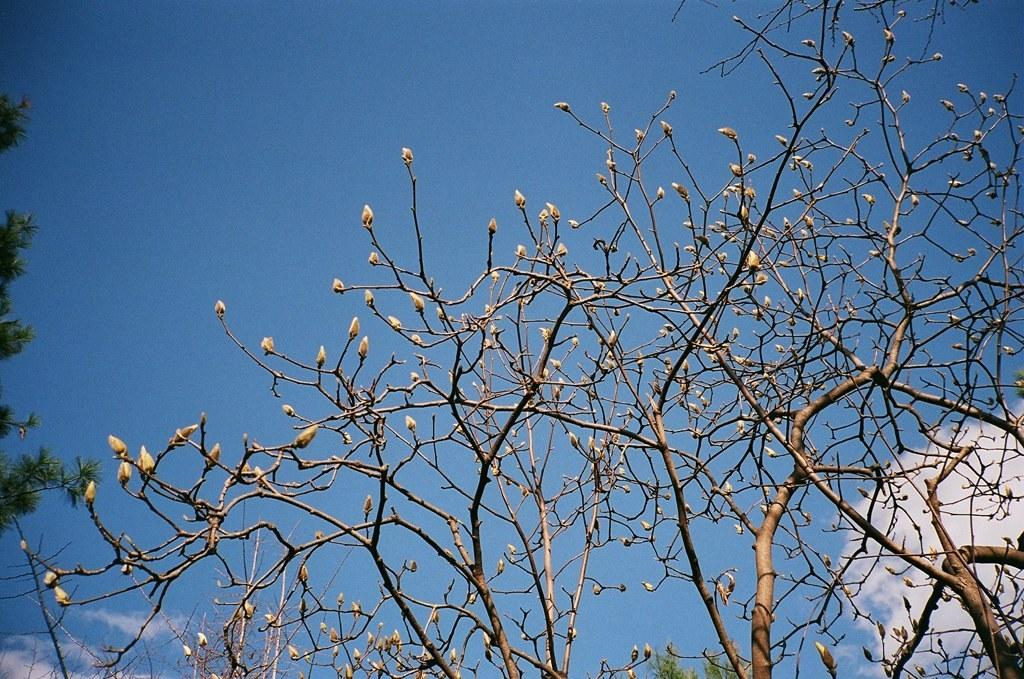What is located on the left side of the image? There is a tree on the left side of the image. What is present on the right back side of the image? There is a tree on the right back side of the image. Can you describe the condition of one of the trees in the image? There is a dried tree in the image. What can be seen in the sky in the image? There are clouds in the sky in the image. What type of quilt can be seen hanging from the dried tree in the image? There is no quilt present in the image, and therefore no such object can be observed hanging from the dried tree. What songs are being sung by the trees in the image? Trees do not have the ability to sing songs, so this question cannot be answered based on the image. 